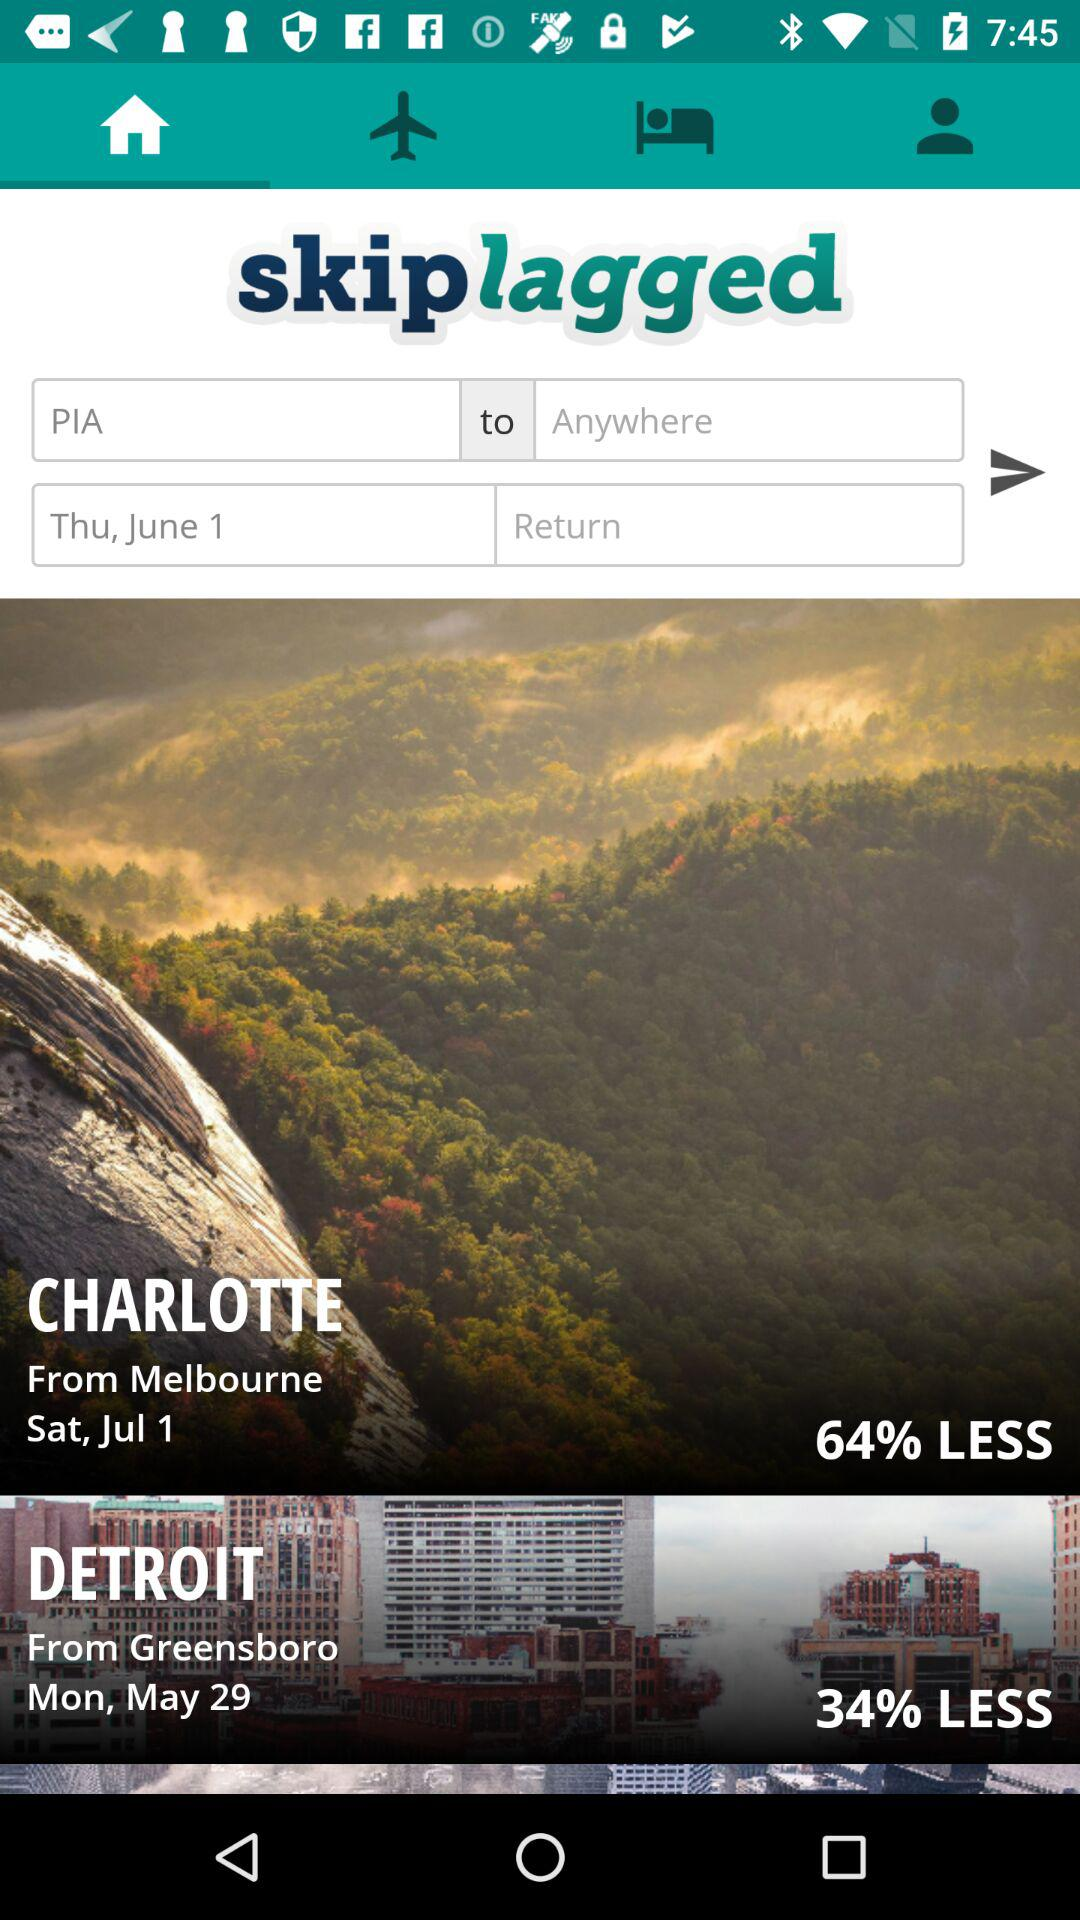How much of a discount is there on the tickets to Charlotte? There is a discount of 64% on the tickets to Charlotte. 